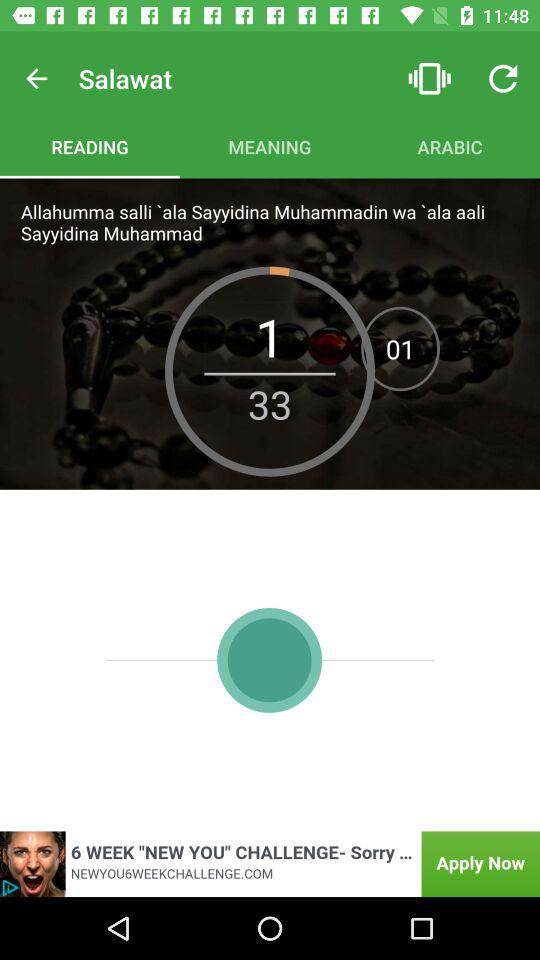How many numbers of "READING" have been completed? The number of "READING" that has been completed is 1. 